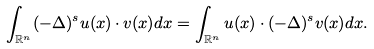<formula> <loc_0><loc_0><loc_500><loc_500>\int _ { \mathbb { R } ^ { n } } ( - \Delta ) ^ { s } u ( x ) \cdot v ( x ) d x = \int _ { \mathbb { R } ^ { n } } u ( x ) \cdot ( - \Delta ) ^ { s } v ( x ) d x .</formula> 